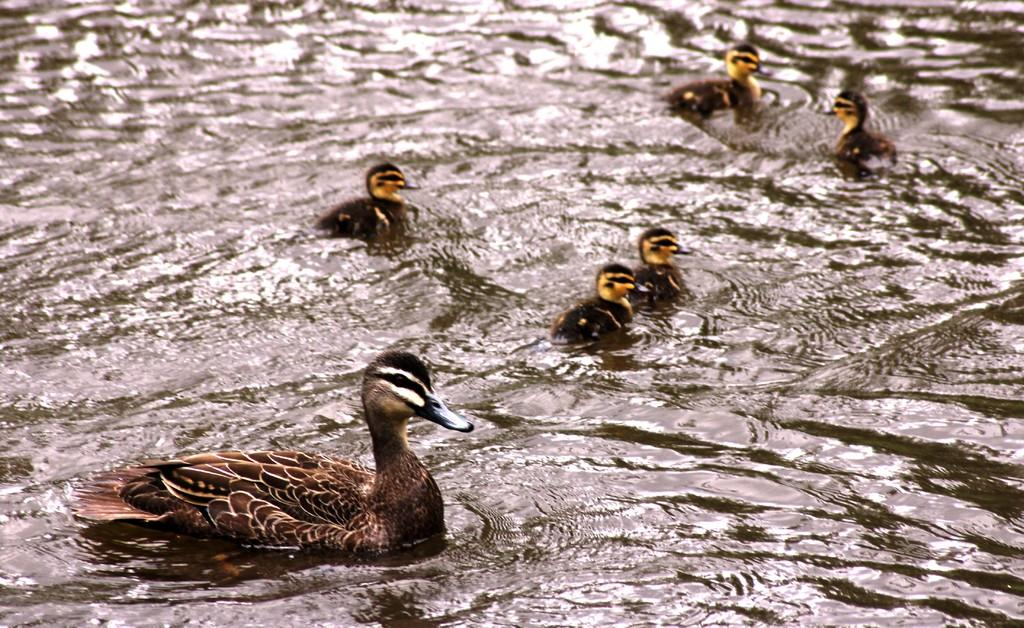What type of animal is present in the image? There is a duck in the image. Are there any baby ducks in the image? Yes, there are ducklings in the image. Where are the duck and ducklings located? The duck and ducklings are in the water. What type of paper can be seen floating in the water in the image? There is no paper present in the image; it features a duck and ducklings in the water. Can you tell me how many trucks are visible in the image? There are no trucks present in the image. 